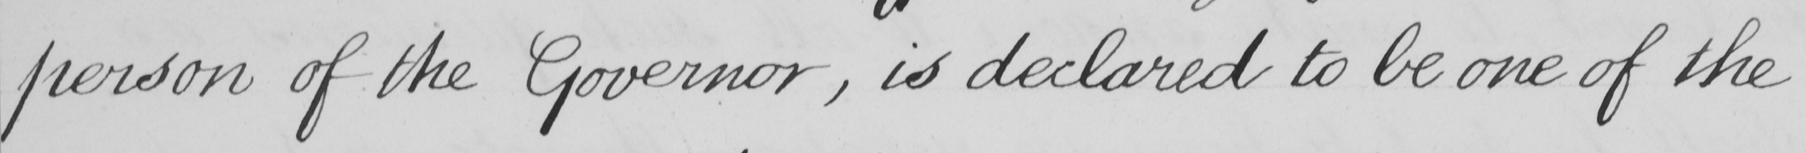What is written in this line of handwriting? person of the Governor , is declared to be one of the 